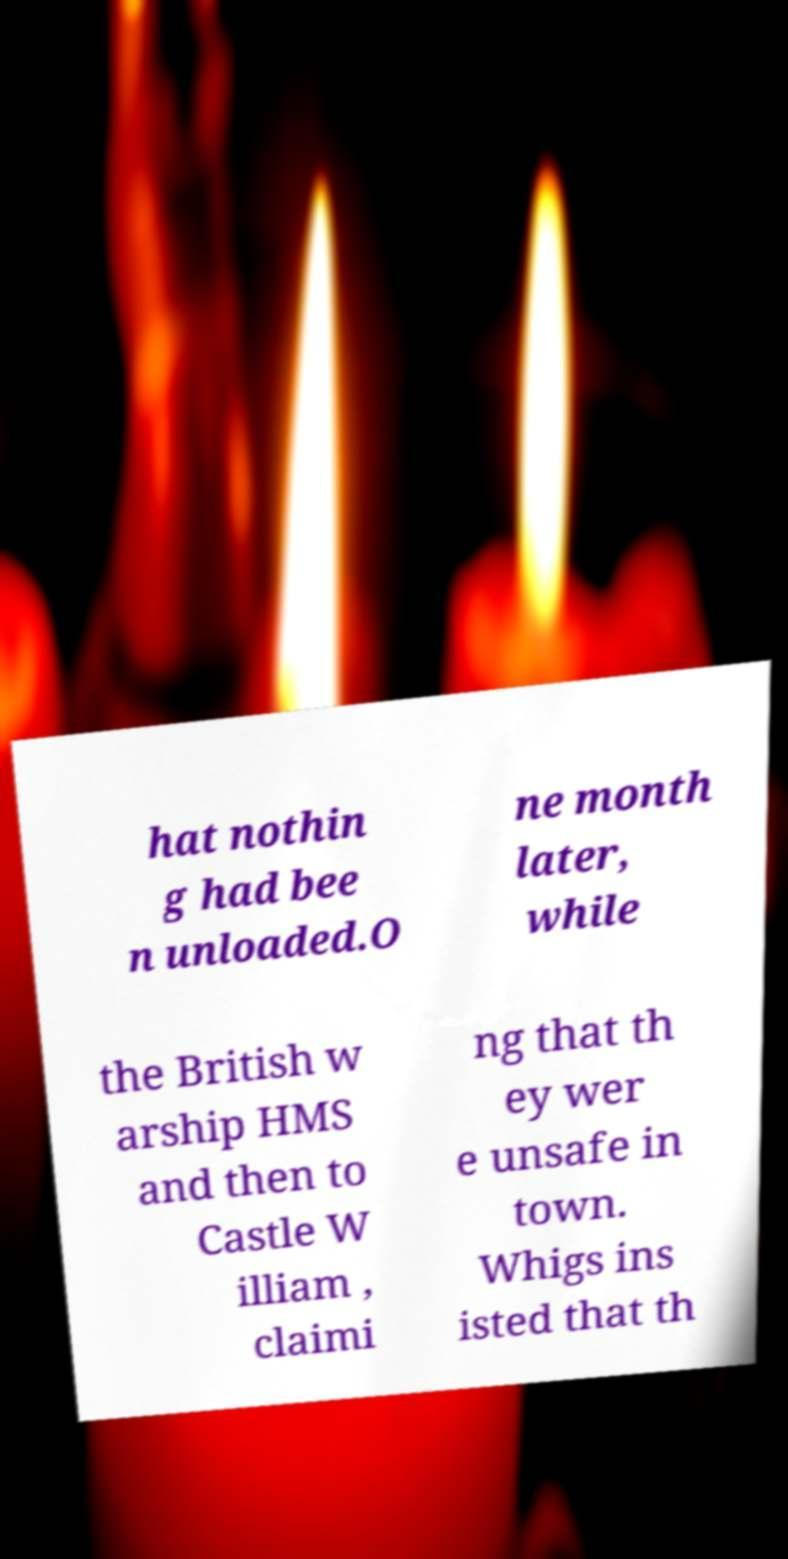What messages or text are displayed in this image? I need them in a readable, typed format. hat nothin g had bee n unloaded.O ne month later, while the British w arship HMS and then to Castle W illiam , claimi ng that th ey wer e unsafe in town. Whigs ins isted that th 